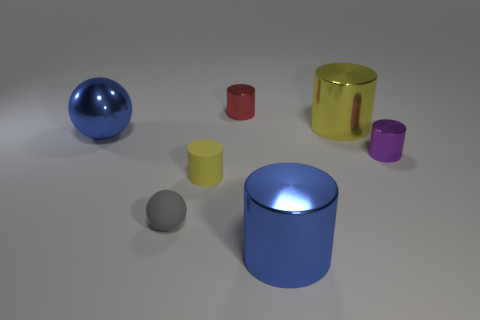Subtract all green spheres. How many yellow cylinders are left? 2 Subtract all small red cylinders. How many cylinders are left? 4 Subtract 1 cylinders. How many cylinders are left? 4 Add 1 large yellow metal objects. How many objects exist? 8 Subtract all red cylinders. How many cylinders are left? 4 Subtract all cylinders. How many objects are left? 2 Subtract all brown cylinders. Subtract all purple balls. How many cylinders are left? 5 Subtract 0 gray cubes. How many objects are left? 7 Subtract all brown cylinders. Subtract all metallic cylinders. How many objects are left? 3 Add 4 blue cylinders. How many blue cylinders are left? 5 